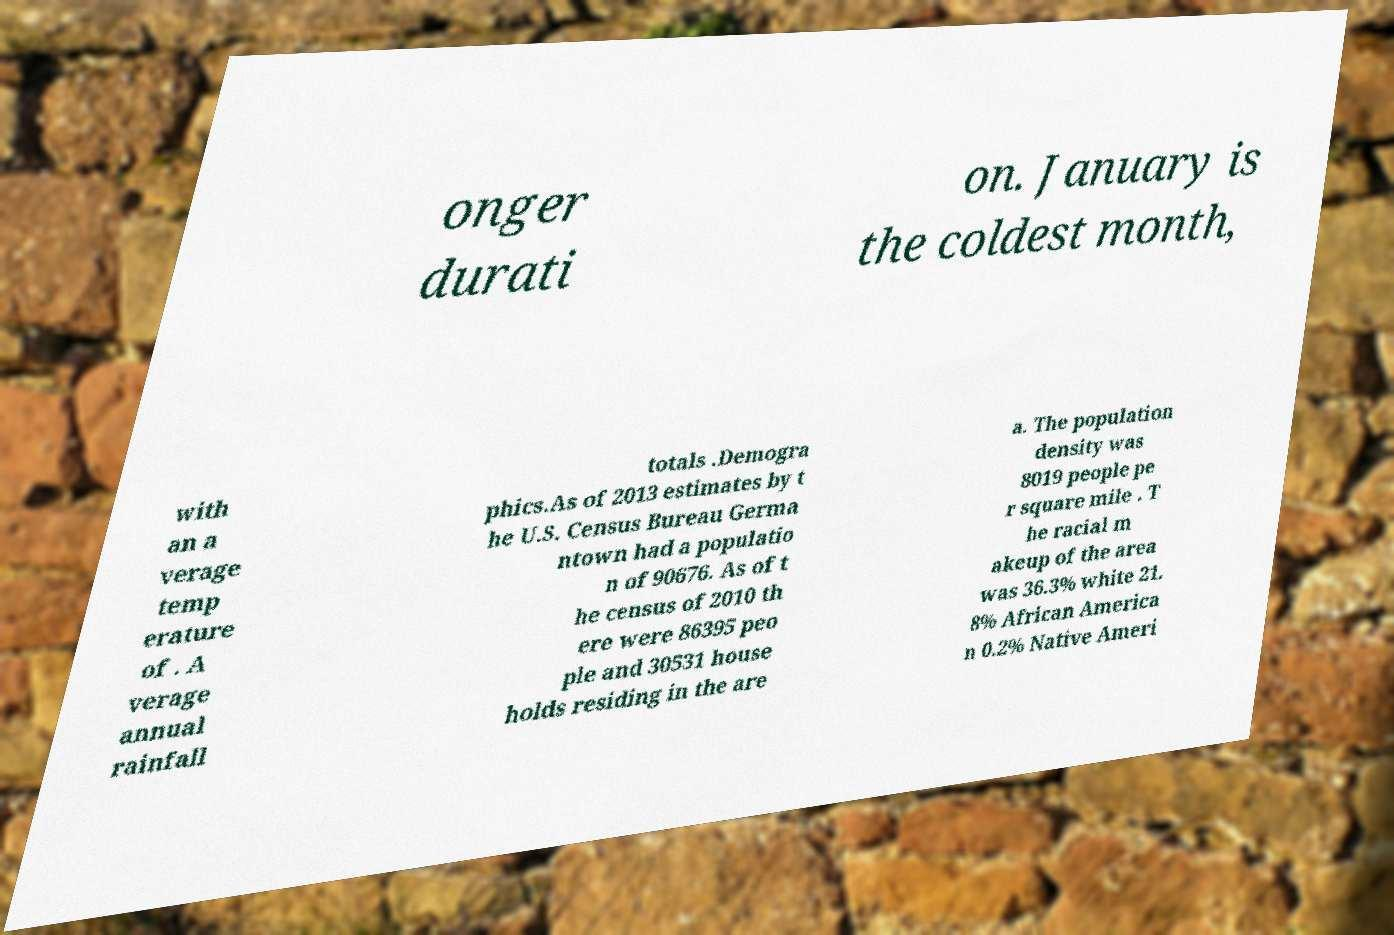Please identify and transcribe the text found in this image. onger durati on. January is the coldest month, with an a verage temp erature of . A verage annual rainfall totals .Demogra phics.As of 2013 estimates by t he U.S. Census Bureau Germa ntown had a populatio n of 90676. As of t he census of 2010 th ere were 86395 peo ple and 30531 house holds residing in the are a. The population density was 8019 people pe r square mile . T he racial m akeup of the area was 36.3% white 21. 8% African America n 0.2% Native Ameri 